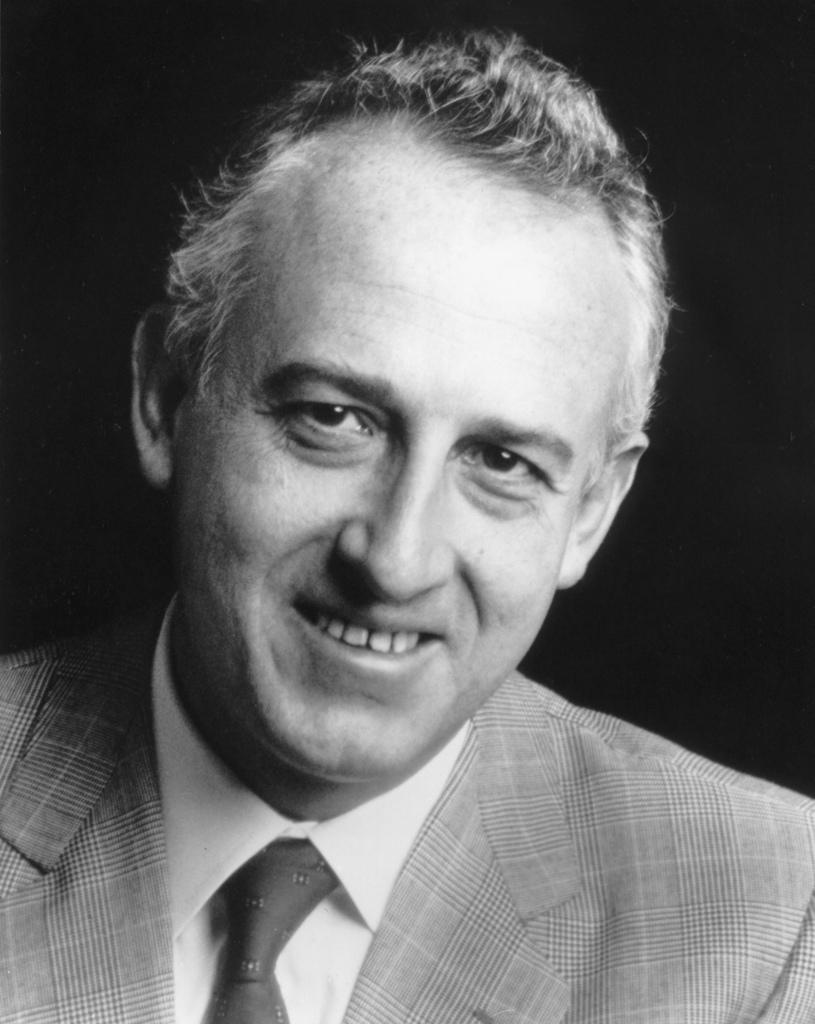What is the main subject of the image? The main subject of the image is a black and white photograph of a man. What type of clothing is the man wearing? The man is wearing a blazer, a tie, and a shirt. What is the man's facial expression in the image? The man is smiling in the image. What can be seen behind the man in the photograph? There is a dark background behind the man. What type of government is depicted in the image? There is no depiction of a government in the image; it features a photograph of a man wearing a blazer, tie, and shirt, with a dark background. Is there any smoke visible in the image? There is no smoke present in the image. 